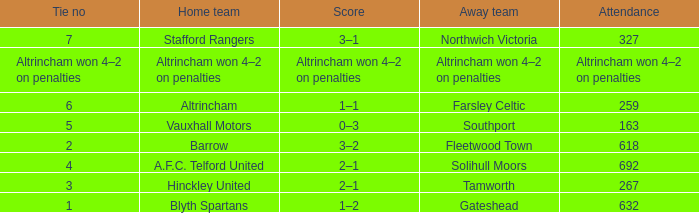What was the attendance for the away team Solihull Moors? 692.0. 